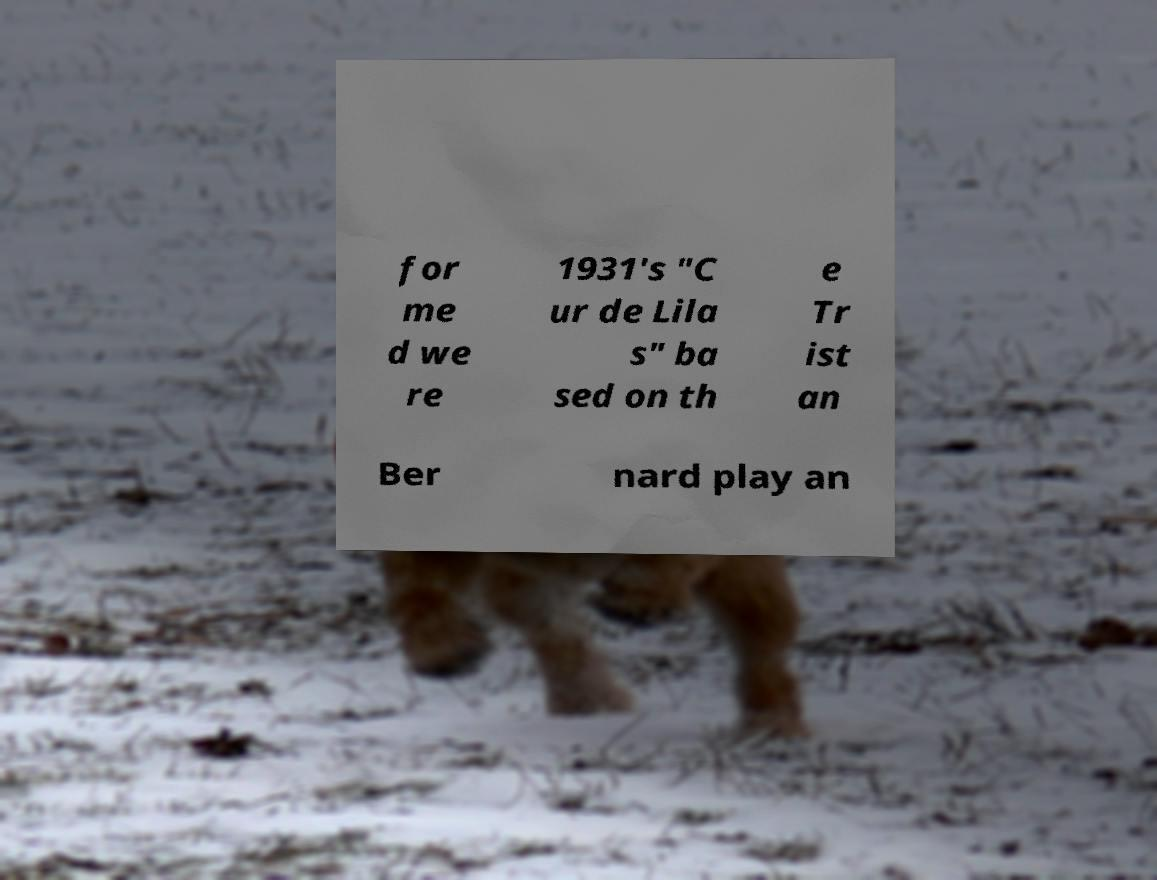Can you read and provide the text displayed in the image?This photo seems to have some interesting text. Can you extract and type it out for me? for me d we re 1931's "C ur de Lila s" ba sed on th e Tr ist an Ber nard play an 